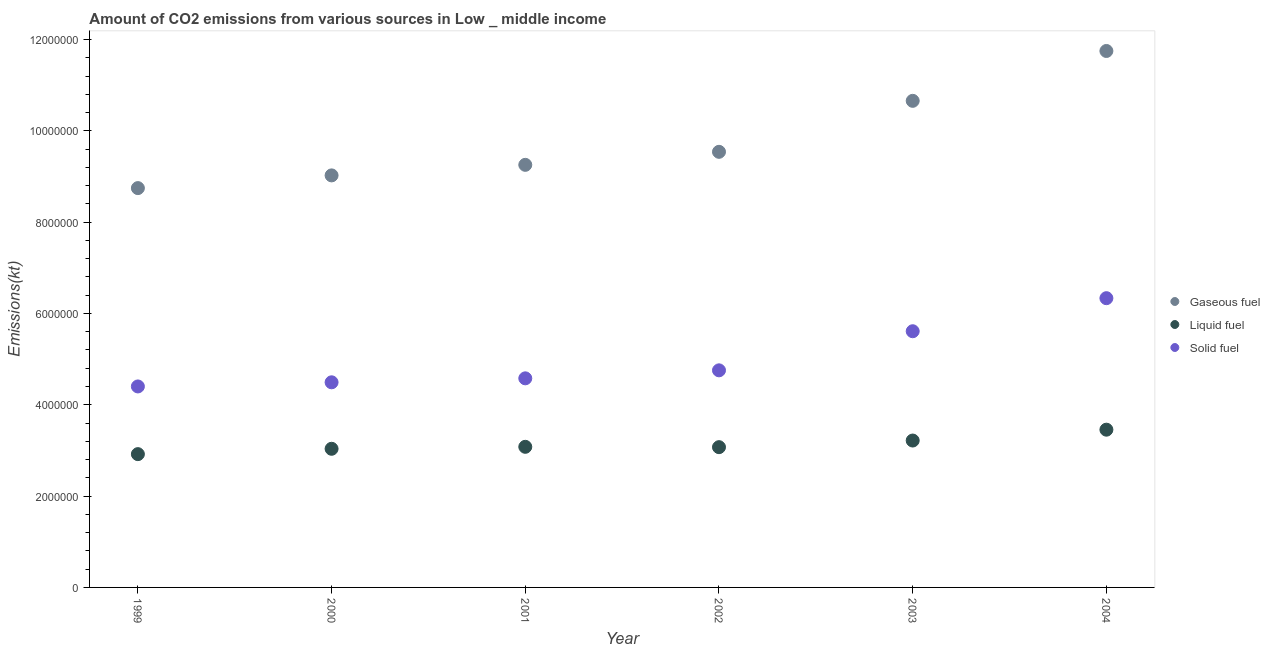How many different coloured dotlines are there?
Offer a very short reply. 3. Is the number of dotlines equal to the number of legend labels?
Ensure brevity in your answer.  Yes. What is the amount of co2 emissions from gaseous fuel in 1999?
Your response must be concise. 8.75e+06. Across all years, what is the maximum amount of co2 emissions from gaseous fuel?
Make the answer very short. 1.17e+07. Across all years, what is the minimum amount of co2 emissions from gaseous fuel?
Your response must be concise. 8.75e+06. In which year was the amount of co2 emissions from gaseous fuel maximum?
Keep it short and to the point. 2004. What is the total amount of co2 emissions from solid fuel in the graph?
Your answer should be compact. 3.02e+07. What is the difference between the amount of co2 emissions from gaseous fuel in 1999 and that in 2004?
Offer a terse response. -3.00e+06. What is the difference between the amount of co2 emissions from gaseous fuel in 2002 and the amount of co2 emissions from liquid fuel in 2004?
Make the answer very short. 6.08e+06. What is the average amount of co2 emissions from liquid fuel per year?
Ensure brevity in your answer.  3.13e+06. In the year 2002, what is the difference between the amount of co2 emissions from liquid fuel and amount of co2 emissions from solid fuel?
Keep it short and to the point. -1.68e+06. In how many years, is the amount of co2 emissions from gaseous fuel greater than 4400000 kt?
Ensure brevity in your answer.  6. What is the ratio of the amount of co2 emissions from gaseous fuel in 1999 to that in 2002?
Keep it short and to the point. 0.92. Is the difference between the amount of co2 emissions from solid fuel in 2002 and 2004 greater than the difference between the amount of co2 emissions from gaseous fuel in 2002 and 2004?
Your response must be concise. Yes. What is the difference between the highest and the second highest amount of co2 emissions from liquid fuel?
Your answer should be very brief. 2.38e+05. What is the difference between the highest and the lowest amount of co2 emissions from gaseous fuel?
Your answer should be compact. 3.00e+06. Is the amount of co2 emissions from liquid fuel strictly less than the amount of co2 emissions from gaseous fuel over the years?
Make the answer very short. Yes. What is the difference between two consecutive major ticks on the Y-axis?
Your response must be concise. 2.00e+06. Are the values on the major ticks of Y-axis written in scientific E-notation?
Offer a terse response. No. Where does the legend appear in the graph?
Offer a very short reply. Center right. How many legend labels are there?
Keep it short and to the point. 3. How are the legend labels stacked?
Provide a short and direct response. Vertical. What is the title of the graph?
Provide a succinct answer. Amount of CO2 emissions from various sources in Low _ middle income. What is the label or title of the Y-axis?
Your answer should be very brief. Emissions(kt). What is the Emissions(kt) of Gaseous fuel in 1999?
Your answer should be compact. 8.75e+06. What is the Emissions(kt) in Liquid fuel in 1999?
Ensure brevity in your answer.  2.92e+06. What is the Emissions(kt) of Solid fuel in 1999?
Keep it short and to the point. 4.40e+06. What is the Emissions(kt) in Gaseous fuel in 2000?
Your response must be concise. 9.02e+06. What is the Emissions(kt) in Liquid fuel in 2000?
Offer a terse response. 3.04e+06. What is the Emissions(kt) in Solid fuel in 2000?
Offer a very short reply. 4.49e+06. What is the Emissions(kt) of Gaseous fuel in 2001?
Your answer should be very brief. 9.25e+06. What is the Emissions(kt) in Liquid fuel in 2001?
Give a very brief answer. 3.08e+06. What is the Emissions(kt) in Solid fuel in 2001?
Your answer should be compact. 4.58e+06. What is the Emissions(kt) of Gaseous fuel in 2002?
Offer a terse response. 9.54e+06. What is the Emissions(kt) in Liquid fuel in 2002?
Keep it short and to the point. 3.07e+06. What is the Emissions(kt) of Solid fuel in 2002?
Provide a short and direct response. 4.75e+06. What is the Emissions(kt) in Gaseous fuel in 2003?
Ensure brevity in your answer.  1.07e+07. What is the Emissions(kt) in Liquid fuel in 2003?
Ensure brevity in your answer.  3.22e+06. What is the Emissions(kt) in Solid fuel in 2003?
Your response must be concise. 5.61e+06. What is the Emissions(kt) in Gaseous fuel in 2004?
Offer a terse response. 1.17e+07. What is the Emissions(kt) in Liquid fuel in 2004?
Offer a very short reply. 3.45e+06. What is the Emissions(kt) of Solid fuel in 2004?
Your response must be concise. 6.33e+06. Across all years, what is the maximum Emissions(kt) of Gaseous fuel?
Keep it short and to the point. 1.17e+07. Across all years, what is the maximum Emissions(kt) of Liquid fuel?
Provide a succinct answer. 3.45e+06. Across all years, what is the maximum Emissions(kt) of Solid fuel?
Your response must be concise. 6.33e+06. Across all years, what is the minimum Emissions(kt) of Gaseous fuel?
Keep it short and to the point. 8.75e+06. Across all years, what is the minimum Emissions(kt) of Liquid fuel?
Your response must be concise. 2.92e+06. Across all years, what is the minimum Emissions(kt) of Solid fuel?
Your answer should be very brief. 4.40e+06. What is the total Emissions(kt) in Gaseous fuel in the graph?
Your answer should be compact. 5.90e+07. What is the total Emissions(kt) of Liquid fuel in the graph?
Offer a very short reply. 1.88e+07. What is the total Emissions(kt) of Solid fuel in the graph?
Make the answer very short. 3.02e+07. What is the difference between the Emissions(kt) of Gaseous fuel in 1999 and that in 2000?
Your answer should be compact. -2.78e+05. What is the difference between the Emissions(kt) of Liquid fuel in 1999 and that in 2000?
Make the answer very short. -1.17e+05. What is the difference between the Emissions(kt) of Solid fuel in 1999 and that in 2000?
Offer a very short reply. -9.06e+04. What is the difference between the Emissions(kt) in Gaseous fuel in 1999 and that in 2001?
Keep it short and to the point. -5.10e+05. What is the difference between the Emissions(kt) in Liquid fuel in 1999 and that in 2001?
Provide a succinct answer. -1.60e+05. What is the difference between the Emissions(kt) in Solid fuel in 1999 and that in 2001?
Your response must be concise. -1.78e+05. What is the difference between the Emissions(kt) of Gaseous fuel in 1999 and that in 2002?
Make the answer very short. -7.95e+05. What is the difference between the Emissions(kt) of Liquid fuel in 1999 and that in 2002?
Offer a terse response. -1.53e+05. What is the difference between the Emissions(kt) of Solid fuel in 1999 and that in 2002?
Your answer should be compact. -3.53e+05. What is the difference between the Emissions(kt) in Gaseous fuel in 1999 and that in 2003?
Offer a very short reply. -1.91e+06. What is the difference between the Emissions(kt) of Liquid fuel in 1999 and that in 2003?
Make the answer very short. -2.98e+05. What is the difference between the Emissions(kt) in Solid fuel in 1999 and that in 2003?
Your answer should be compact. -1.21e+06. What is the difference between the Emissions(kt) in Gaseous fuel in 1999 and that in 2004?
Ensure brevity in your answer.  -3.00e+06. What is the difference between the Emissions(kt) in Liquid fuel in 1999 and that in 2004?
Give a very brief answer. -5.36e+05. What is the difference between the Emissions(kt) of Solid fuel in 1999 and that in 2004?
Your answer should be compact. -1.93e+06. What is the difference between the Emissions(kt) of Gaseous fuel in 2000 and that in 2001?
Ensure brevity in your answer.  -2.31e+05. What is the difference between the Emissions(kt) in Liquid fuel in 2000 and that in 2001?
Your answer should be very brief. -4.31e+04. What is the difference between the Emissions(kt) in Solid fuel in 2000 and that in 2001?
Offer a very short reply. -8.70e+04. What is the difference between the Emissions(kt) in Gaseous fuel in 2000 and that in 2002?
Your response must be concise. -5.16e+05. What is the difference between the Emissions(kt) of Liquid fuel in 2000 and that in 2002?
Provide a short and direct response. -3.56e+04. What is the difference between the Emissions(kt) in Solid fuel in 2000 and that in 2002?
Keep it short and to the point. -2.62e+05. What is the difference between the Emissions(kt) in Gaseous fuel in 2000 and that in 2003?
Your answer should be compact. -1.63e+06. What is the difference between the Emissions(kt) in Liquid fuel in 2000 and that in 2003?
Keep it short and to the point. -1.81e+05. What is the difference between the Emissions(kt) in Solid fuel in 2000 and that in 2003?
Provide a short and direct response. -1.12e+06. What is the difference between the Emissions(kt) in Gaseous fuel in 2000 and that in 2004?
Provide a succinct answer. -2.72e+06. What is the difference between the Emissions(kt) of Liquid fuel in 2000 and that in 2004?
Offer a very short reply. -4.18e+05. What is the difference between the Emissions(kt) of Solid fuel in 2000 and that in 2004?
Offer a very short reply. -1.84e+06. What is the difference between the Emissions(kt) of Gaseous fuel in 2001 and that in 2002?
Your answer should be very brief. -2.85e+05. What is the difference between the Emissions(kt) of Liquid fuel in 2001 and that in 2002?
Offer a very short reply. 7448.95. What is the difference between the Emissions(kt) in Solid fuel in 2001 and that in 2002?
Your response must be concise. -1.75e+05. What is the difference between the Emissions(kt) in Gaseous fuel in 2001 and that in 2003?
Provide a short and direct response. -1.40e+06. What is the difference between the Emissions(kt) in Liquid fuel in 2001 and that in 2003?
Make the answer very short. -1.38e+05. What is the difference between the Emissions(kt) in Solid fuel in 2001 and that in 2003?
Your answer should be compact. -1.03e+06. What is the difference between the Emissions(kt) of Gaseous fuel in 2001 and that in 2004?
Provide a succinct answer. -2.49e+06. What is the difference between the Emissions(kt) in Liquid fuel in 2001 and that in 2004?
Give a very brief answer. -3.75e+05. What is the difference between the Emissions(kt) in Solid fuel in 2001 and that in 2004?
Keep it short and to the point. -1.76e+06. What is the difference between the Emissions(kt) in Gaseous fuel in 2002 and that in 2003?
Your answer should be very brief. -1.12e+06. What is the difference between the Emissions(kt) of Liquid fuel in 2002 and that in 2003?
Provide a succinct answer. -1.45e+05. What is the difference between the Emissions(kt) of Solid fuel in 2002 and that in 2003?
Make the answer very short. -8.56e+05. What is the difference between the Emissions(kt) in Gaseous fuel in 2002 and that in 2004?
Make the answer very short. -2.21e+06. What is the difference between the Emissions(kt) of Liquid fuel in 2002 and that in 2004?
Your answer should be very brief. -3.83e+05. What is the difference between the Emissions(kt) in Solid fuel in 2002 and that in 2004?
Offer a very short reply. -1.58e+06. What is the difference between the Emissions(kt) in Gaseous fuel in 2003 and that in 2004?
Your answer should be very brief. -1.09e+06. What is the difference between the Emissions(kt) in Liquid fuel in 2003 and that in 2004?
Your answer should be compact. -2.38e+05. What is the difference between the Emissions(kt) of Solid fuel in 2003 and that in 2004?
Provide a succinct answer. -7.24e+05. What is the difference between the Emissions(kt) of Gaseous fuel in 1999 and the Emissions(kt) of Liquid fuel in 2000?
Ensure brevity in your answer.  5.71e+06. What is the difference between the Emissions(kt) of Gaseous fuel in 1999 and the Emissions(kt) of Solid fuel in 2000?
Provide a short and direct response. 4.25e+06. What is the difference between the Emissions(kt) in Liquid fuel in 1999 and the Emissions(kt) in Solid fuel in 2000?
Your answer should be very brief. -1.57e+06. What is the difference between the Emissions(kt) of Gaseous fuel in 1999 and the Emissions(kt) of Liquid fuel in 2001?
Make the answer very short. 5.67e+06. What is the difference between the Emissions(kt) of Gaseous fuel in 1999 and the Emissions(kt) of Solid fuel in 2001?
Offer a very short reply. 4.17e+06. What is the difference between the Emissions(kt) in Liquid fuel in 1999 and the Emissions(kt) in Solid fuel in 2001?
Your answer should be very brief. -1.66e+06. What is the difference between the Emissions(kt) in Gaseous fuel in 1999 and the Emissions(kt) in Liquid fuel in 2002?
Your answer should be very brief. 5.67e+06. What is the difference between the Emissions(kt) in Gaseous fuel in 1999 and the Emissions(kt) in Solid fuel in 2002?
Your answer should be compact. 3.99e+06. What is the difference between the Emissions(kt) of Liquid fuel in 1999 and the Emissions(kt) of Solid fuel in 2002?
Provide a short and direct response. -1.84e+06. What is the difference between the Emissions(kt) of Gaseous fuel in 1999 and the Emissions(kt) of Liquid fuel in 2003?
Offer a terse response. 5.53e+06. What is the difference between the Emissions(kt) in Gaseous fuel in 1999 and the Emissions(kt) in Solid fuel in 2003?
Your answer should be very brief. 3.13e+06. What is the difference between the Emissions(kt) of Liquid fuel in 1999 and the Emissions(kt) of Solid fuel in 2003?
Provide a short and direct response. -2.69e+06. What is the difference between the Emissions(kt) of Gaseous fuel in 1999 and the Emissions(kt) of Liquid fuel in 2004?
Ensure brevity in your answer.  5.29e+06. What is the difference between the Emissions(kt) of Gaseous fuel in 1999 and the Emissions(kt) of Solid fuel in 2004?
Provide a short and direct response. 2.41e+06. What is the difference between the Emissions(kt) of Liquid fuel in 1999 and the Emissions(kt) of Solid fuel in 2004?
Your answer should be compact. -3.42e+06. What is the difference between the Emissions(kt) in Gaseous fuel in 2000 and the Emissions(kt) in Liquid fuel in 2001?
Make the answer very short. 5.94e+06. What is the difference between the Emissions(kt) of Gaseous fuel in 2000 and the Emissions(kt) of Solid fuel in 2001?
Provide a short and direct response. 4.44e+06. What is the difference between the Emissions(kt) in Liquid fuel in 2000 and the Emissions(kt) in Solid fuel in 2001?
Your response must be concise. -1.54e+06. What is the difference between the Emissions(kt) of Gaseous fuel in 2000 and the Emissions(kt) of Liquid fuel in 2002?
Make the answer very short. 5.95e+06. What is the difference between the Emissions(kt) of Gaseous fuel in 2000 and the Emissions(kt) of Solid fuel in 2002?
Keep it short and to the point. 4.27e+06. What is the difference between the Emissions(kt) in Liquid fuel in 2000 and the Emissions(kt) in Solid fuel in 2002?
Your response must be concise. -1.72e+06. What is the difference between the Emissions(kt) in Gaseous fuel in 2000 and the Emissions(kt) in Liquid fuel in 2003?
Provide a short and direct response. 5.81e+06. What is the difference between the Emissions(kt) in Gaseous fuel in 2000 and the Emissions(kt) in Solid fuel in 2003?
Provide a succinct answer. 3.41e+06. What is the difference between the Emissions(kt) of Liquid fuel in 2000 and the Emissions(kt) of Solid fuel in 2003?
Provide a short and direct response. -2.57e+06. What is the difference between the Emissions(kt) in Gaseous fuel in 2000 and the Emissions(kt) in Liquid fuel in 2004?
Ensure brevity in your answer.  5.57e+06. What is the difference between the Emissions(kt) of Gaseous fuel in 2000 and the Emissions(kt) of Solid fuel in 2004?
Offer a very short reply. 2.69e+06. What is the difference between the Emissions(kt) in Liquid fuel in 2000 and the Emissions(kt) in Solid fuel in 2004?
Keep it short and to the point. -3.30e+06. What is the difference between the Emissions(kt) in Gaseous fuel in 2001 and the Emissions(kt) in Liquid fuel in 2002?
Keep it short and to the point. 6.18e+06. What is the difference between the Emissions(kt) of Gaseous fuel in 2001 and the Emissions(kt) of Solid fuel in 2002?
Ensure brevity in your answer.  4.50e+06. What is the difference between the Emissions(kt) in Liquid fuel in 2001 and the Emissions(kt) in Solid fuel in 2002?
Offer a very short reply. -1.67e+06. What is the difference between the Emissions(kt) of Gaseous fuel in 2001 and the Emissions(kt) of Liquid fuel in 2003?
Make the answer very short. 6.04e+06. What is the difference between the Emissions(kt) of Gaseous fuel in 2001 and the Emissions(kt) of Solid fuel in 2003?
Ensure brevity in your answer.  3.64e+06. What is the difference between the Emissions(kt) in Liquid fuel in 2001 and the Emissions(kt) in Solid fuel in 2003?
Offer a terse response. -2.53e+06. What is the difference between the Emissions(kt) in Gaseous fuel in 2001 and the Emissions(kt) in Liquid fuel in 2004?
Your response must be concise. 5.80e+06. What is the difference between the Emissions(kt) in Gaseous fuel in 2001 and the Emissions(kt) in Solid fuel in 2004?
Your answer should be very brief. 2.92e+06. What is the difference between the Emissions(kt) in Liquid fuel in 2001 and the Emissions(kt) in Solid fuel in 2004?
Keep it short and to the point. -3.26e+06. What is the difference between the Emissions(kt) of Gaseous fuel in 2002 and the Emissions(kt) of Liquid fuel in 2003?
Your answer should be very brief. 6.32e+06. What is the difference between the Emissions(kt) of Gaseous fuel in 2002 and the Emissions(kt) of Solid fuel in 2003?
Your answer should be very brief. 3.93e+06. What is the difference between the Emissions(kt) in Liquid fuel in 2002 and the Emissions(kt) in Solid fuel in 2003?
Your answer should be compact. -2.54e+06. What is the difference between the Emissions(kt) in Gaseous fuel in 2002 and the Emissions(kt) in Liquid fuel in 2004?
Offer a terse response. 6.08e+06. What is the difference between the Emissions(kt) of Gaseous fuel in 2002 and the Emissions(kt) of Solid fuel in 2004?
Make the answer very short. 3.21e+06. What is the difference between the Emissions(kt) of Liquid fuel in 2002 and the Emissions(kt) of Solid fuel in 2004?
Make the answer very short. -3.26e+06. What is the difference between the Emissions(kt) in Gaseous fuel in 2003 and the Emissions(kt) in Liquid fuel in 2004?
Give a very brief answer. 7.20e+06. What is the difference between the Emissions(kt) of Gaseous fuel in 2003 and the Emissions(kt) of Solid fuel in 2004?
Keep it short and to the point. 4.32e+06. What is the difference between the Emissions(kt) of Liquid fuel in 2003 and the Emissions(kt) of Solid fuel in 2004?
Offer a terse response. -3.12e+06. What is the average Emissions(kt) in Gaseous fuel per year?
Provide a succinct answer. 9.83e+06. What is the average Emissions(kt) of Liquid fuel per year?
Make the answer very short. 3.13e+06. What is the average Emissions(kt) of Solid fuel per year?
Make the answer very short. 5.03e+06. In the year 1999, what is the difference between the Emissions(kt) of Gaseous fuel and Emissions(kt) of Liquid fuel?
Your answer should be very brief. 5.83e+06. In the year 1999, what is the difference between the Emissions(kt) of Gaseous fuel and Emissions(kt) of Solid fuel?
Your answer should be very brief. 4.34e+06. In the year 1999, what is the difference between the Emissions(kt) of Liquid fuel and Emissions(kt) of Solid fuel?
Offer a terse response. -1.48e+06. In the year 2000, what is the difference between the Emissions(kt) in Gaseous fuel and Emissions(kt) in Liquid fuel?
Provide a succinct answer. 5.99e+06. In the year 2000, what is the difference between the Emissions(kt) in Gaseous fuel and Emissions(kt) in Solid fuel?
Provide a short and direct response. 4.53e+06. In the year 2000, what is the difference between the Emissions(kt) in Liquid fuel and Emissions(kt) in Solid fuel?
Offer a terse response. -1.46e+06. In the year 2001, what is the difference between the Emissions(kt) of Gaseous fuel and Emissions(kt) of Liquid fuel?
Give a very brief answer. 6.18e+06. In the year 2001, what is the difference between the Emissions(kt) of Gaseous fuel and Emissions(kt) of Solid fuel?
Provide a succinct answer. 4.68e+06. In the year 2001, what is the difference between the Emissions(kt) of Liquid fuel and Emissions(kt) of Solid fuel?
Your answer should be very brief. -1.50e+06. In the year 2002, what is the difference between the Emissions(kt) of Gaseous fuel and Emissions(kt) of Liquid fuel?
Provide a short and direct response. 6.47e+06. In the year 2002, what is the difference between the Emissions(kt) of Gaseous fuel and Emissions(kt) of Solid fuel?
Provide a short and direct response. 4.79e+06. In the year 2002, what is the difference between the Emissions(kt) in Liquid fuel and Emissions(kt) in Solid fuel?
Offer a terse response. -1.68e+06. In the year 2003, what is the difference between the Emissions(kt) of Gaseous fuel and Emissions(kt) of Liquid fuel?
Offer a terse response. 7.44e+06. In the year 2003, what is the difference between the Emissions(kt) in Gaseous fuel and Emissions(kt) in Solid fuel?
Ensure brevity in your answer.  5.05e+06. In the year 2003, what is the difference between the Emissions(kt) in Liquid fuel and Emissions(kt) in Solid fuel?
Offer a very short reply. -2.39e+06. In the year 2004, what is the difference between the Emissions(kt) of Gaseous fuel and Emissions(kt) of Liquid fuel?
Your answer should be compact. 8.29e+06. In the year 2004, what is the difference between the Emissions(kt) in Gaseous fuel and Emissions(kt) in Solid fuel?
Give a very brief answer. 5.41e+06. In the year 2004, what is the difference between the Emissions(kt) of Liquid fuel and Emissions(kt) of Solid fuel?
Make the answer very short. -2.88e+06. What is the ratio of the Emissions(kt) of Gaseous fuel in 1999 to that in 2000?
Ensure brevity in your answer.  0.97. What is the ratio of the Emissions(kt) of Liquid fuel in 1999 to that in 2000?
Give a very brief answer. 0.96. What is the ratio of the Emissions(kt) in Solid fuel in 1999 to that in 2000?
Ensure brevity in your answer.  0.98. What is the ratio of the Emissions(kt) in Gaseous fuel in 1999 to that in 2001?
Your response must be concise. 0.94. What is the ratio of the Emissions(kt) in Liquid fuel in 1999 to that in 2001?
Ensure brevity in your answer.  0.95. What is the ratio of the Emissions(kt) of Solid fuel in 1999 to that in 2001?
Provide a short and direct response. 0.96. What is the ratio of the Emissions(kt) of Gaseous fuel in 1999 to that in 2002?
Provide a succinct answer. 0.92. What is the ratio of the Emissions(kt) in Liquid fuel in 1999 to that in 2002?
Provide a succinct answer. 0.95. What is the ratio of the Emissions(kt) of Solid fuel in 1999 to that in 2002?
Offer a very short reply. 0.93. What is the ratio of the Emissions(kt) in Gaseous fuel in 1999 to that in 2003?
Offer a terse response. 0.82. What is the ratio of the Emissions(kt) in Liquid fuel in 1999 to that in 2003?
Make the answer very short. 0.91. What is the ratio of the Emissions(kt) in Solid fuel in 1999 to that in 2003?
Provide a short and direct response. 0.78. What is the ratio of the Emissions(kt) in Gaseous fuel in 1999 to that in 2004?
Your answer should be very brief. 0.74. What is the ratio of the Emissions(kt) in Liquid fuel in 1999 to that in 2004?
Give a very brief answer. 0.84. What is the ratio of the Emissions(kt) in Solid fuel in 1999 to that in 2004?
Offer a terse response. 0.69. What is the ratio of the Emissions(kt) in Gaseous fuel in 2000 to that in 2001?
Your response must be concise. 0.97. What is the ratio of the Emissions(kt) of Liquid fuel in 2000 to that in 2001?
Your answer should be very brief. 0.99. What is the ratio of the Emissions(kt) of Gaseous fuel in 2000 to that in 2002?
Your response must be concise. 0.95. What is the ratio of the Emissions(kt) in Liquid fuel in 2000 to that in 2002?
Your answer should be compact. 0.99. What is the ratio of the Emissions(kt) in Solid fuel in 2000 to that in 2002?
Offer a terse response. 0.94. What is the ratio of the Emissions(kt) in Gaseous fuel in 2000 to that in 2003?
Offer a terse response. 0.85. What is the ratio of the Emissions(kt) in Liquid fuel in 2000 to that in 2003?
Keep it short and to the point. 0.94. What is the ratio of the Emissions(kt) in Solid fuel in 2000 to that in 2003?
Ensure brevity in your answer.  0.8. What is the ratio of the Emissions(kt) in Gaseous fuel in 2000 to that in 2004?
Make the answer very short. 0.77. What is the ratio of the Emissions(kt) in Liquid fuel in 2000 to that in 2004?
Your answer should be very brief. 0.88. What is the ratio of the Emissions(kt) in Solid fuel in 2000 to that in 2004?
Make the answer very short. 0.71. What is the ratio of the Emissions(kt) of Gaseous fuel in 2001 to that in 2002?
Your answer should be compact. 0.97. What is the ratio of the Emissions(kt) in Solid fuel in 2001 to that in 2002?
Keep it short and to the point. 0.96. What is the ratio of the Emissions(kt) in Gaseous fuel in 2001 to that in 2003?
Your answer should be very brief. 0.87. What is the ratio of the Emissions(kt) in Liquid fuel in 2001 to that in 2003?
Keep it short and to the point. 0.96. What is the ratio of the Emissions(kt) of Solid fuel in 2001 to that in 2003?
Your answer should be compact. 0.82. What is the ratio of the Emissions(kt) in Gaseous fuel in 2001 to that in 2004?
Keep it short and to the point. 0.79. What is the ratio of the Emissions(kt) of Liquid fuel in 2001 to that in 2004?
Your answer should be compact. 0.89. What is the ratio of the Emissions(kt) in Solid fuel in 2001 to that in 2004?
Your response must be concise. 0.72. What is the ratio of the Emissions(kt) in Gaseous fuel in 2002 to that in 2003?
Your answer should be very brief. 0.9. What is the ratio of the Emissions(kt) in Liquid fuel in 2002 to that in 2003?
Offer a very short reply. 0.95. What is the ratio of the Emissions(kt) of Solid fuel in 2002 to that in 2003?
Your answer should be very brief. 0.85. What is the ratio of the Emissions(kt) of Gaseous fuel in 2002 to that in 2004?
Ensure brevity in your answer.  0.81. What is the ratio of the Emissions(kt) of Liquid fuel in 2002 to that in 2004?
Your answer should be very brief. 0.89. What is the ratio of the Emissions(kt) of Solid fuel in 2002 to that in 2004?
Make the answer very short. 0.75. What is the ratio of the Emissions(kt) of Gaseous fuel in 2003 to that in 2004?
Your response must be concise. 0.91. What is the ratio of the Emissions(kt) of Liquid fuel in 2003 to that in 2004?
Your answer should be compact. 0.93. What is the ratio of the Emissions(kt) in Solid fuel in 2003 to that in 2004?
Make the answer very short. 0.89. What is the difference between the highest and the second highest Emissions(kt) of Gaseous fuel?
Your answer should be very brief. 1.09e+06. What is the difference between the highest and the second highest Emissions(kt) in Liquid fuel?
Provide a short and direct response. 2.38e+05. What is the difference between the highest and the second highest Emissions(kt) of Solid fuel?
Offer a terse response. 7.24e+05. What is the difference between the highest and the lowest Emissions(kt) in Gaseous fuel?
Ensure brevity in your answer.  3.00e+06. What is the difference between the highest and the lowest Emissions(kt) of Liquid fuel?
Offer a very short reply. 5.36e+05. What is the difference between the highest and the lowest Emissions(kt) of Solid fuel?
Provide a succinct answer. 1.93e+06. 